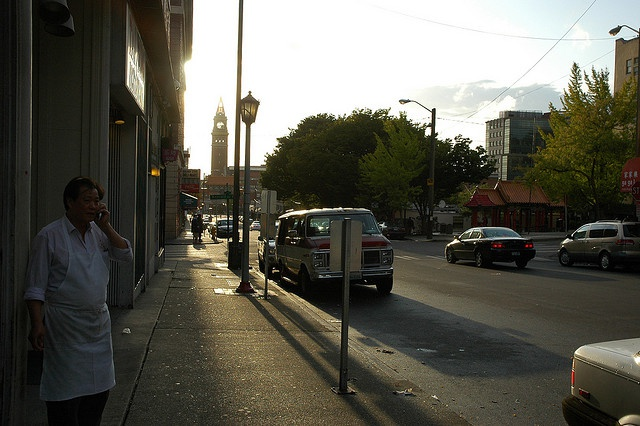Describe the objects in this image and their specific colors. I can see people in black and gray tones, truck in black, gray, darkgreen, and ivory tones, car in black, darkgray, gray, and darkgreen tones, car in black, gray, and darkgray tones, and car in black, gray, purple, and darkgray tones in this image. 